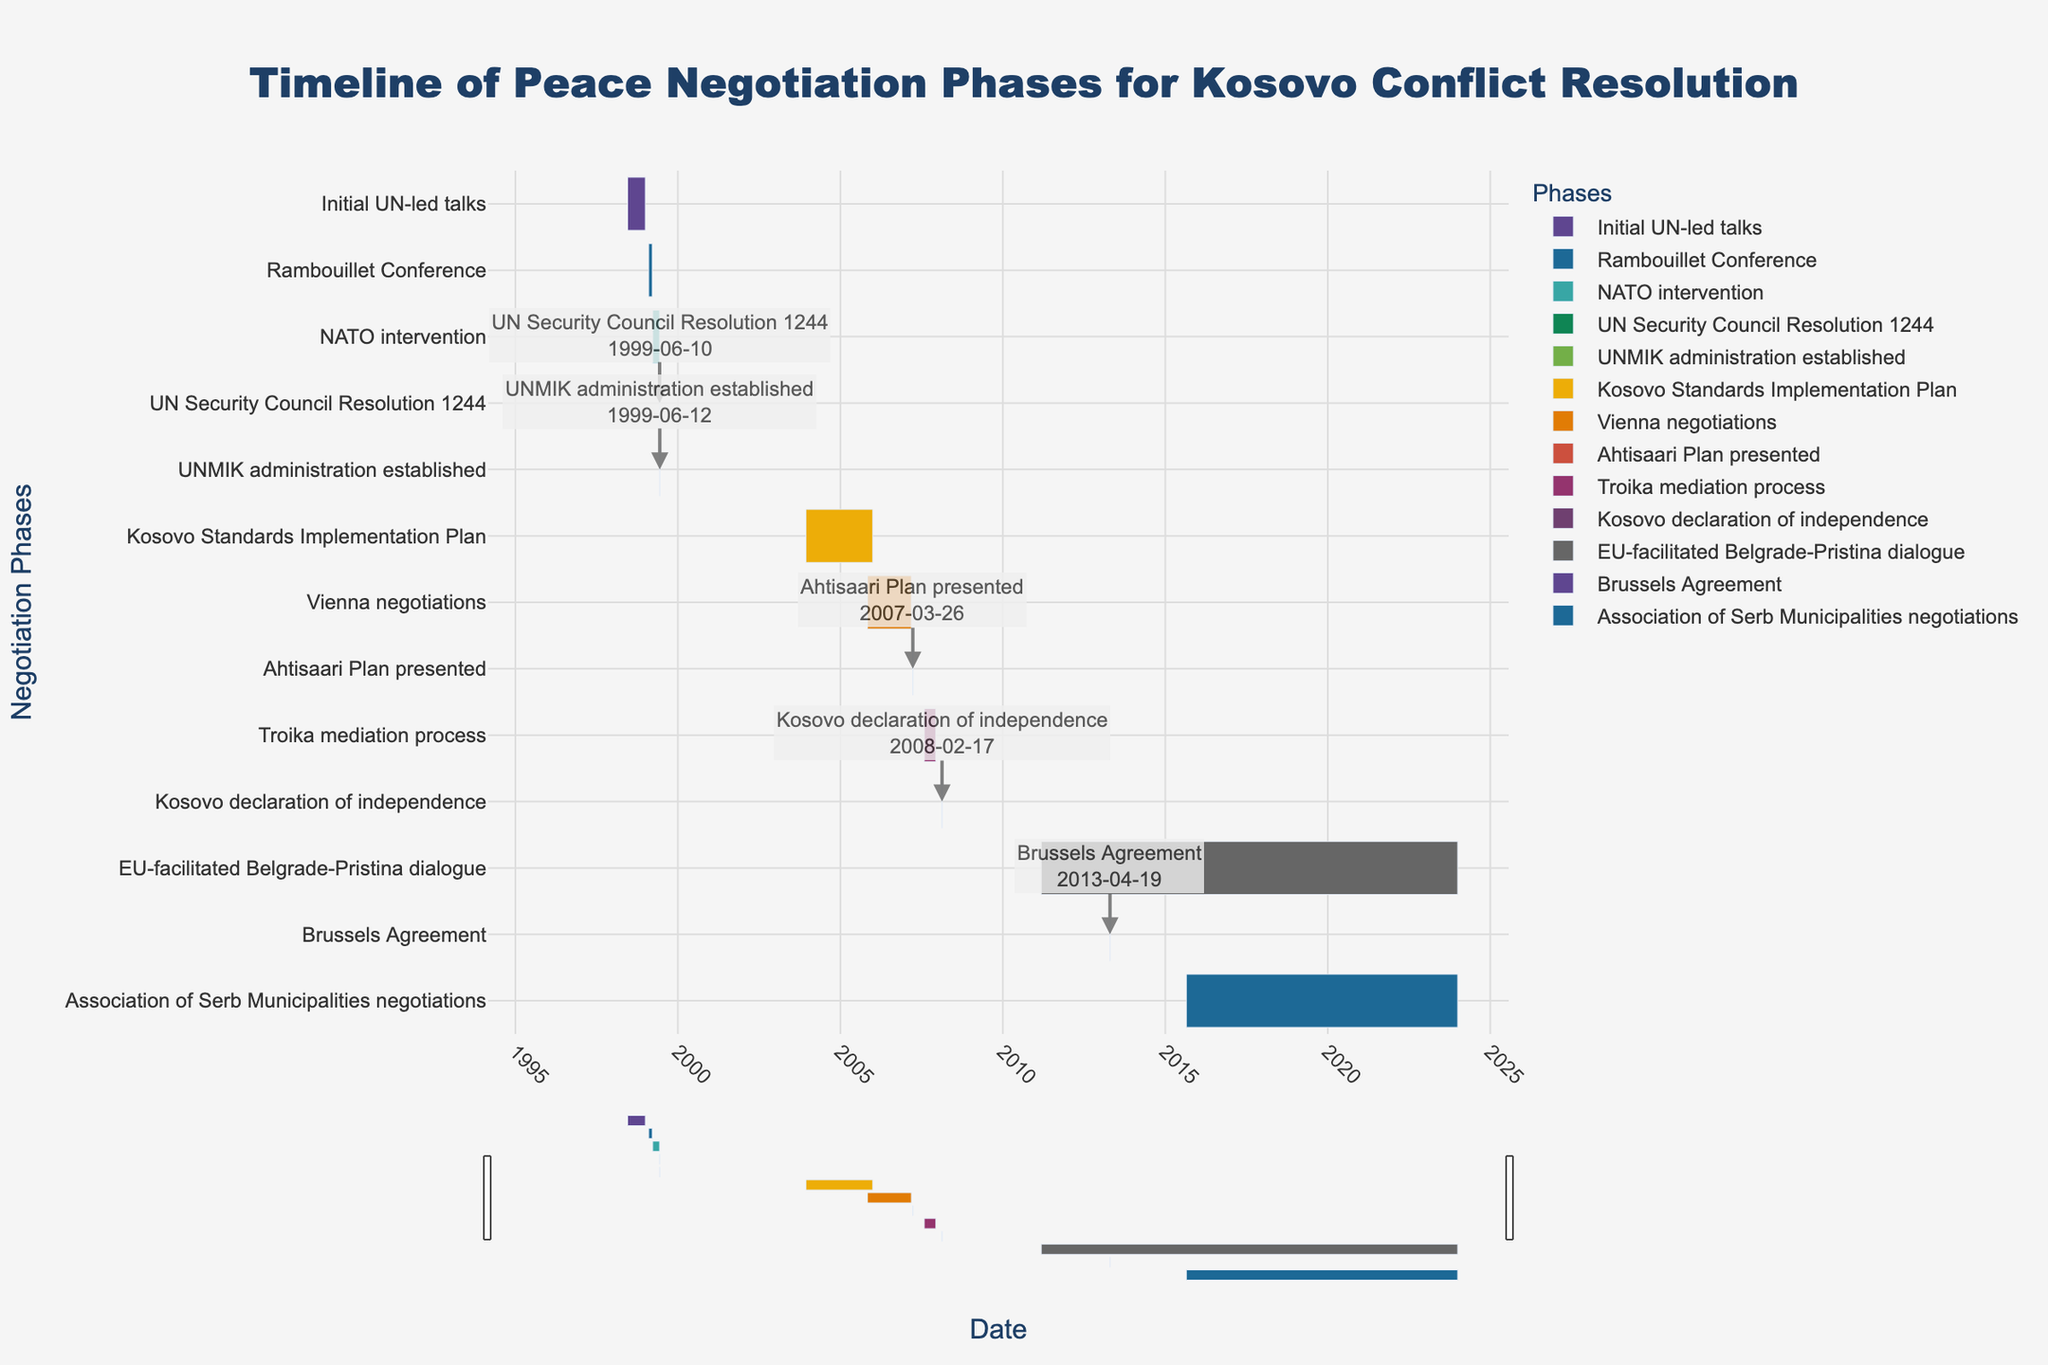When does the "Initial UN-led talks" phase start and end? The "Initial UN-led talks" phase starts on June 15, 1998, and ends on December 31, 1998.
Answer: June 15, 1998 to December 31, 1998 Which phase lasts the shortest and what is its duration? The "UN Security Council Resolution 1244" phase lasts the shortest, with a duration of just 1 day (June 10, 1999).
Answer: UN Security Council Resolution 1244, 1 day How long did the "Vienna negotiations" last? The "Vienna negotiations" started on November 1, 2005, and ended on March 10, 2007. The duration is calculated as (March 10, 2007 - November 1, 2005) + 1 = 495 days.
Answer: 495 days Compare the duration of "NATO intervention" and the "Troika mediation process". Which one took longer? By how many days? The "NATO intervention" lasted from March 24, 1999, to June 10, 1999, for a total of 79 days. The "Troika mediation process" lasted from August 1, 2007, to December 10, 2007, for a total of 132 days. The "Troika mediation process" took longer by 53 days.
Answer: Troika mediation process, 53 days Identify two phases that overlap in time. When is this overlap? The "NATO intervention" (March 24, 1999, to June 10, 1999) and the "UN Security Council Resolution 1244" (June 10, 1999) overlap on June 10, 1999.
Answer: NATO intervention and UN Security Council Resolution 1244, June 10, 1999 What is the most recent peace negotiation phase displayed in the chart, and when did it start? The most recent peace negotiation phase displayed is the "Association of Serb Municipalities negotiations", which started on August 25, 2015.
Answer: Association of Serb Municipalities negotiations, August 25, 2015 Which phase started on February 17, 2008, and what is its significance? The phase that started on February 17, 2008, is the "Kosovo declaration of independence". Its significance is that it marks the formal declaration of independence by Kosovo.
Answer: Kosovo declaration of independence, formal declaration of independence How many days did the "Brussels Agreement" phase last? The "Brussels Agreement" phase lasted for a single day on April 19, 2013.
Answer: 1 day What is the sum of the durations of the "Kosovo Standards Implementation Plan" and the "Vienna negotiations"? The "Kosovo Standards Implementation Plan" lasted from December 10, 2003, to December 31, 2005, for a total of 752 days. The "Vienna negotiations" lasted for 495 days. The sum of their durations is 1247 days.
Answer: 1247 days Which phase took the longest, and how many days did it last? The "EU-facilitated Belgrade-Pristina dialogue" phase is the longest, lasting from March 8, 2011, to December 31, 2023. It will span 4670 days.
Answer: EU-facilitated Belgrade-Pristina dialogue, 4670 days 